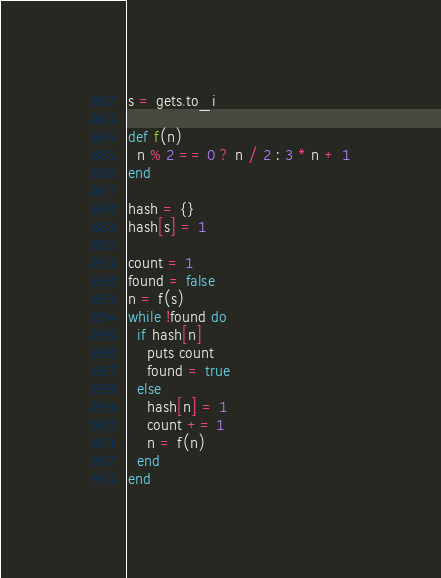Convert code to text. <code><loc_0><loc_0><loc_500><loc_500><_Ruby_>s = gets.to_i

def f(n)
  n % 2 == 0 ? n / 2 : 3 * n + 1
end

hash = {}
hash[s] = 1

count = 1
found = false
n = f(s)
while !found do
  if hash[n]
    puts count
    found = true
  else
    hash[n] = 1
    count += 1
    n = f(n)
  end
end
</code> 